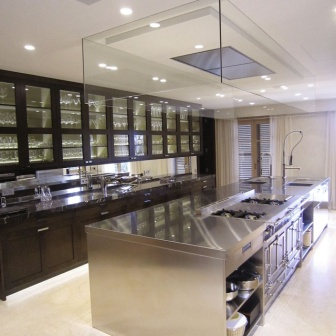Can you create a fictional story involving this kitchen? In a futuristic city where culinary traditions have merged with advanced technology, this kitchen belongs to Luna, a renowned chef and innovative inventor. Luna’s kitchen isn’t just a place to cook; it’s an interactive culinary lab where every surface and appliance has a smart feature. The large central island not only serves as a prepping station but also hosts holographic recipe demonstrations, guiding Luna through her latest culinary experiments.

One evening, as Luna prepared for her weekly 'Galactic Fusion' dinner party, she noticed an anomaly in the kitchen’s lighting system. The lights began to pulse rhythmically, revealing an intricate pattern that projected onto the stainless steel countertop. Intrigued, Luna realized that these lights weren't just malfunctioning—they were conveying a hidden, ancient recipe long lost to Earth’s culinary history.

With each flash of light, Luna deciphered the recipe, integrating ingredients and techniques that bridged the gap between Earth’s past and interstellar future. Her dishes became legendary, combining flavors and aromas that no one had ever imagined. Her kitchen, once just a modern marvel, transformed into a beacon of culinary innovation, where history and future deliciously entwined. What features make this kitchen suitable for hosting a high-end dinner party? This kitchen is perfectly suited for hosting a high-end dinner party due to its combination of functionality and elegance. The spacious layout allows for easy movement and interaction among guests. The large island can serve as a preparation space as well as an area where guests can gather and enjoy appetizers or cocktails. The gleaming stainless steel countertop, paired with the dark wood cabinets and soft lighting, creates a sophisticated ambiance.

The built-in lighting within the cabinets provides a warm, inviting glow that enhances the atmosphere. The ample counter space and high-end appliances ensure that the host can prepare and serve a variety of dishes efficiently. The natural light streaming in from the large windows can be adjusted with the white blinds to set the perfect mood for different times of the day. These features collectively make the kitchen not only practical for preparing an exquisite meal but also an elegant setting for an unforgettable dining experience. 